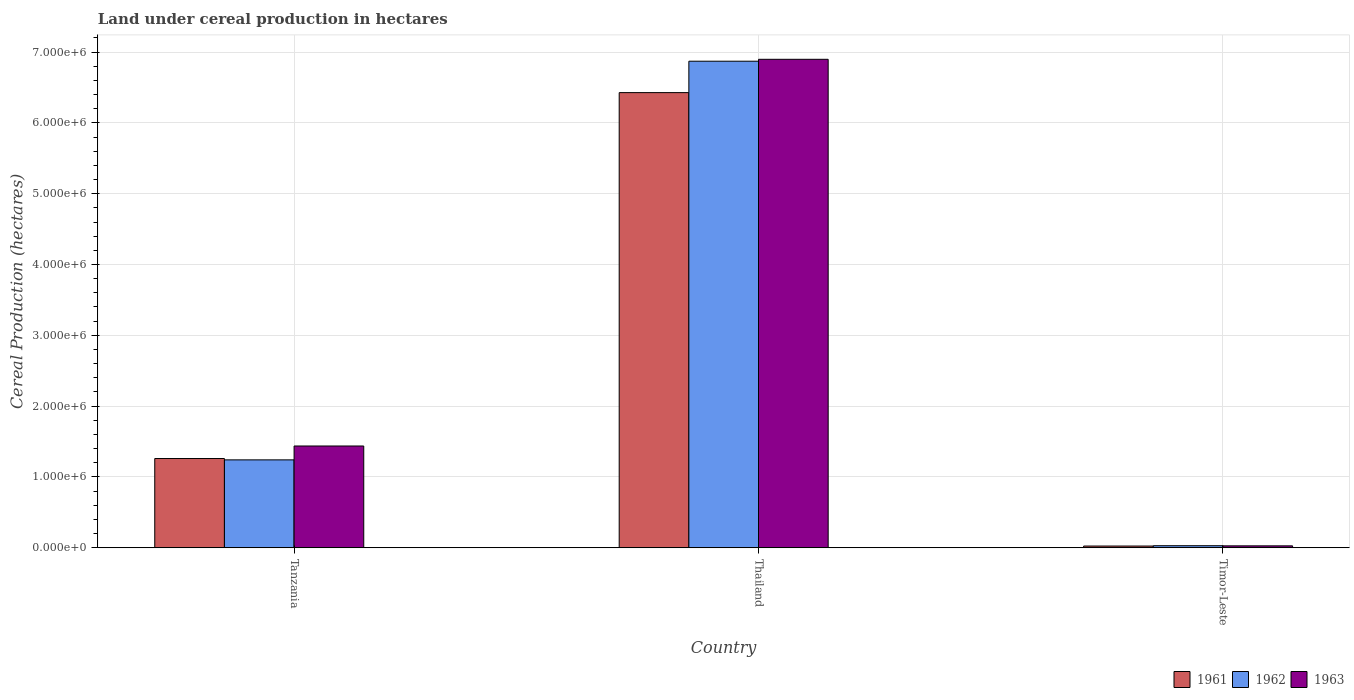Are the number of bars per tick equal to the number of legend labels?
Ensure brevity in your answer.  Yes. What is the label of the 3rd group of bars from the left?
Provide a succinct answer. Timor-Leste. What is the land under cereal production in 1962 in Timor-Leste?
Provide a short and direct response. 2.90e+04. Across all countries, what is the maximum land under cereal production in 1961?
Give a very brief answer. 6.43e+06. Across all countries, what is the minimum land under cereal production in 1962?
Offer a very short reply. 2.90e+04. In which country was the land under cereal production in 1961 maximum?
Offer a very short reply. Thailand. In which country was the land under cereal production in 1963 minimum?
Your answer should be compact. Timor-Leste. What is the total land under cereal production in 1961 in the graph?
Your answer should be very brief. 7.71e+06. What is the difference between the land under cereal production in 1961 in Thailand and that in Timor-Leste?
Offer a terse response. 6.40e+06. What is the difference between the land under cereal production in 1961 in Tanzania and the land under cereal production in 1962 in Thailand?
Provide a succinct answer. -5.61e+06. What is the average land under cereal production in 1961 per country?
Your response must be concise. 2.57e+06. What is the difference between the land under cereal production of/in 1961 and land under cereal production of/in 1962 in Thailand?
Your response must be concise. -4.43e+05. What is the ratio of the land under cereal production in 1962 in Thailand to that in Timor-Leste?
Provide a succinct answer. 236.92. What is the difference between the highest and the second highest land under cereal production in 1961?
Your response must be concise. -6.40e+06. What is the difference between the highest and the lowest land under cereal production in 1962?
Provide a succinct answer. 6.84e+06. Is it the case that in every country, the sum of the land under cereal production in 1963 and land under cereal production in 1962 is greater than the land under cereal production in 1961?
Your answer should be very brief. Yes. How many countries are there in the graph?
Offer a very short reply. 3. What is the difference between two consecutive major ticks on the Y-axis?
Ensure brevity in your answer.  1.00e+06. Are the values on the major ticks of Y-axis written in scientific E-notation?
Offer a terse response. Yes. Does the graph contain any zero values?
Keep it short and to the point. No. Does the graph contain grids?
Provide a short and direct response. Yes. How many legend labels are there?
Provide a succinct answer. 3. How are the legend labels stacked?
Ensure brevity in your answer.  Horizontal. What is the title of the graph?
Keep it short and to the point. Land under cereal production in hectares. What is the label or title of the X-axis?
Ensure brevity in your answer.  Country. What is the label or title of the Y-axis?
Your answer should be compact. Cereal Production (hectares). What is the Cereal Production (hectares) of 1961 in Tanzania?
Offer a terse response. 1.26e+06. What is the Cereal Production (hectares) of 1962 in Tanzania?
Make the answer very short. 1.24e+06. What is the Cereal Production (hectares) in 1963 in Tanzania?
Give a very brief answer. 1.44e+06. What is the Cereal Production (hectares) of 1961 in Thailand?
Ensure brevity in your answer.  6.43e+06. What is the Cereal Production (hectares) in 1962 in Thailand?
Your answer should be compact. 6.87e+06. What is the Cereal Production (hectares) in 1963 in Thailand?
Your answer should be very brief. 6.90e+06. What is the Cereal Production (hectares) of 1961 in Timor-Leste?
Give a very brief answer. 2.44e+04. What is the Cereal Production (hectares) in 1962 in Timor-Leste?
Offer a terse response. 2.90e+04. What is the Cereal Production (hectares) of 1963 in Timor-Leste?
Offer a very short reply. 2.71e+04. Across all countries, what is the maximum Cereal Production (hectares) in 1961?
Your response must be concise. 6.43e+06. Across all countries, what is the maximum Cereal Production (hectares) in 1962?
Your response must be concise. 6.87e+06. Across all countries, what is the maximum Cereal Production (hectares) of 1963?
Your answer should be compact. 6.90e+06. Across all countries, what is the minimum Cereal Production (hectares) in 1961?
Give a very brief answer. 2.44e+04. Across all countries, what is the minimum Cereal Production (hectares) in 1962?
Offer a very short reply. 2.90e+04. Across all countries, what is the minimum Cereal Production (hectares) in 1963?
Keep it short and to the point. 2.71e+04. What is the total Cereal Production (hectares) of 1961 in the graph?
Your answer should be compact. 7.71e+06. What is the total Cereal Production (hectares) in 1962 in the graph?
Your response must be concise. 8.14e+06. What is the total Cereal Production (hectares) of 1963 in the graph?
Offer a very short reply. 8.36e+06. What is the difference between the Cereal Production (hectares) of 1961 in Tanzania and that in Thailand?
Your answer should be very brief. -5.17e+06. What is the difference between the Cereal Production (hectares) of 1962 in Tanzania and that in Thailand?
Make the answer very short. -5.63e+06. What is the difference between the Cereal Production (hectares) in 1963 in Tanzania and that in Thailand?
Give a very brief answer. -5.46e+06. What is the difference between the Cereal Production (hectares) in 1961 in Tanzania and that in Timor-Leste?
Keep it short and to the point. 1.24e+06. What is the difference between the Cereal Production (hectares) in 1962 in Tanzania and that in Timor-Leste?
Offer a very short reply. 1.21e+06. What is the difference between the Cereal Production (hectares) in 1963 in Tanzania and that in Timor-Leste?
Offer a terse response. 1.41e+06. What is the difference between the Cereal Production (hectares) of 1961 in Thailand and that in Timor-Leste?
Ensure brevity in your answer.  6.40e+06. What is the difference between the Cereal Production (hectares) of 1962 in Thailand and that in Timor-Leste?
Give a very brief answer. 6.84e+06. What is the difference between the Cereal Production (hectares) of 1963 in Thailand and that in Timor-Leste?
Your response must be concise. 6.87e+06. What is the difference between the Cereal Production (hectares) of 1961 in Tanzania and the Cereal Production (hectares) of 1962 in Thailand?
Your answer should be very brief. -5.61e+06. What is the difference between the Cereal Production (hectares) of 1961 in Tanzania and the Cereal Production (hectares) of 1963 in Thailand?
Your answer should be very brief. -5.64e+06. What is the difference between the Cereal Production (hectares) of 1962 in Tanzania and the Cereal Production (hectares) of 1963 in Thailand?
Offer a very short reply. -5.66e+06. What is the difference between the Cereal Production (hectares) in 1961 in Tanzania and the Cereal Production (hectares) in 1962 in Timor-Leste?
Your response must be concise. 1.23e+06. What is the difference between the Cereal Production (hectares) of 1961 in Tanzania and the Cereal Production (hectares) of 1963 in Timor-Leste?
Your answer should be compact. 1.23e+06. What is the difference between the Cereal Production (hectares) in 1962 in Tanzania and the Cereal Production (hectares) in 1963 in Timor-Leste?
Offer a terse response. 1.21e+06. What is the difference between the Cereal Production (hectares) of 1961 in Thailand and the Cereal Production (hectares) of 1962 in Timor-Leste?
Your answer should be compact. 6.40e+06. What is the difference between the Cereal Production (hectares) in 1961 in Thailand and the Cereal Production (hectares) in 1963 in Timor-Leste?
Provide a short and direct response. 6.40e+06. What is the difference between the Cereal Production (hectares) in 1962 in Thailand and the Cereal Production (hectares) in 1963 in Timor-Leste?
Keep it short and to the point. 6.84e+06. What is the average Cereal Production (hectares) of 1961 per country?
Your response must be concise. 2.57e+06. What is the average Cereal Production (hectares) of 1962 per country?
Give a very brief answer. 2.71e+06. What is the average Cereal Production (hectares) in 1963 per country?
Your answer should be compact. 2.79e+06. What is the difference between the Cereal Production (hectares) in 1961 and Cereal Production (hectares) in 1962 in Tanzania?
Offer a very short reply. 1.90e+04. What is the difference between the Cereal Production (hectares) of 1961 and Cereal Production (hectares) of 1963 in Tanzania?
Your response must be concise. -1.77e+05. What is the difference between the Cereal Production (hectares) in 1962 and Cereal Production (hectares) in 1963 in Tanzania?
Your response must be concise. -1.96e+05. What is the difference between the Cereal Production (hectares) of 1961 and Cereal Production (hectares) of 1962 in Thailand?
Provide a short and direct response. -4.43e+05. What is the difference between the Cereal Production (hectares) in 1961 and Cereal Production (hectares) in 1963 in Thailand?
Offer a very short reply. -4.70e+05. What is the difference between the Cereal Production (hectares) of 1962 and Cereal Production (hectares) of 1963 in Thailand?
Keep it short and to the point. -2.71e+04. What is the difference between the Cereal Production (hectares) of 1961 and Cereal Production (hectares) of 1962 in Timor-Leste?
Offer a very short reply. -4600. What is the difference between the Cereal Production (hectares) of 1961 and Cereal Production (hectares) of 1963 in Timor-Leste?
Keep it short and to the point. -2700. What is the difference between the Cereal Production (hectares) in 1962 and Cereal Production (hectares) in 1963 in Timor-Leste?
Your answer should be compact. 1900. What is the ratio of the Cereal Production (hectares) in 1961 in Tanzania to that in Thailand?
Provide a succinct answer. 0.2. What is the ratio of the Cereal Production (hectares) of 1962 in Tanzania to that in Thailand?
Ensure brevity in your answer.  0.18. What is the ratio of the Cereal Production (hectares) of 1963 in Tanzania to that in Thailand?
Make the answer very short. 0.21. What is the ratio of the Cereal Production (hectares) in 1961 in Tanzania to that in Timor-Leste?
Provide a short and direct response. 51.64. What is the ratio of the Cereal Production (hectares) in 1962 in Tanzania to that in Timor-Leste?
Provide a short and direct response. 42.8. What is the ratio of the Cereal Production (hectares) in 1963 in Tanzania to that in Timor-Leste?
Your response must be concise. 53.03. What is the ratio of the Cereal Production (hectares) of 1961 in Thailand to that in Timor-Leste?
Your answer should be very brief. 263.41. What is the ratio of the Cereal Production (hectares) in 1962 in Thailand to that in Timor-Leste?
Your answer should be compact. 236.92. What is the ratio of the Cereal Production (hectares) of 1963 in Thailand to that in Timor-Leste?
Provide a short and direct response. 254.53. What is the difference between the highest and the second highest Cereal Production (hectares) of 1961?
Give a very brief answer. 5.17e+06. What is the difference between the highest and the second highest Cereal Production (hectares) of 1962?
Your answer should be compact. 5.63e+06. What is the difference between the highest and the second highest Cereal Production (hectares) of 1963?
Ensure brevity in your answer.  5.46e+06. What is the difference between the highest and the lowest Cereal Production (hectares) of 1961?
Keep it short and to the point. 6.40e+06. What is the difference between the highest and the lowest Cereal Production (hectares) of 1962?
Provide a short and direct response. 6.84e+06. What is the difference between the highest and the lowest Cereal Production (hectares) in 1963?
Your answer should be very brief. 6.87e+06. 